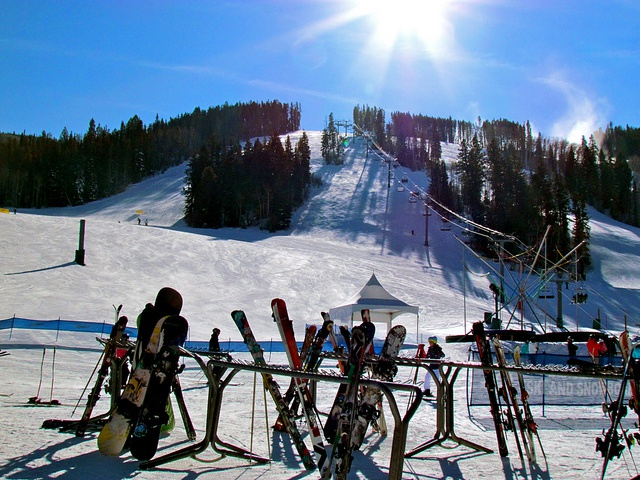Describe the objects in this image and their specific colors. I can see skis in gray, black, maroon, and lightgray tones, snowboard in gray, black, teal, and darkgreen tones, snowboard in gray, black, and olive tones, skis in gray, black, lightgray, and maroon tones, and snowboard in gray, black, and darkblue tones in this image. 